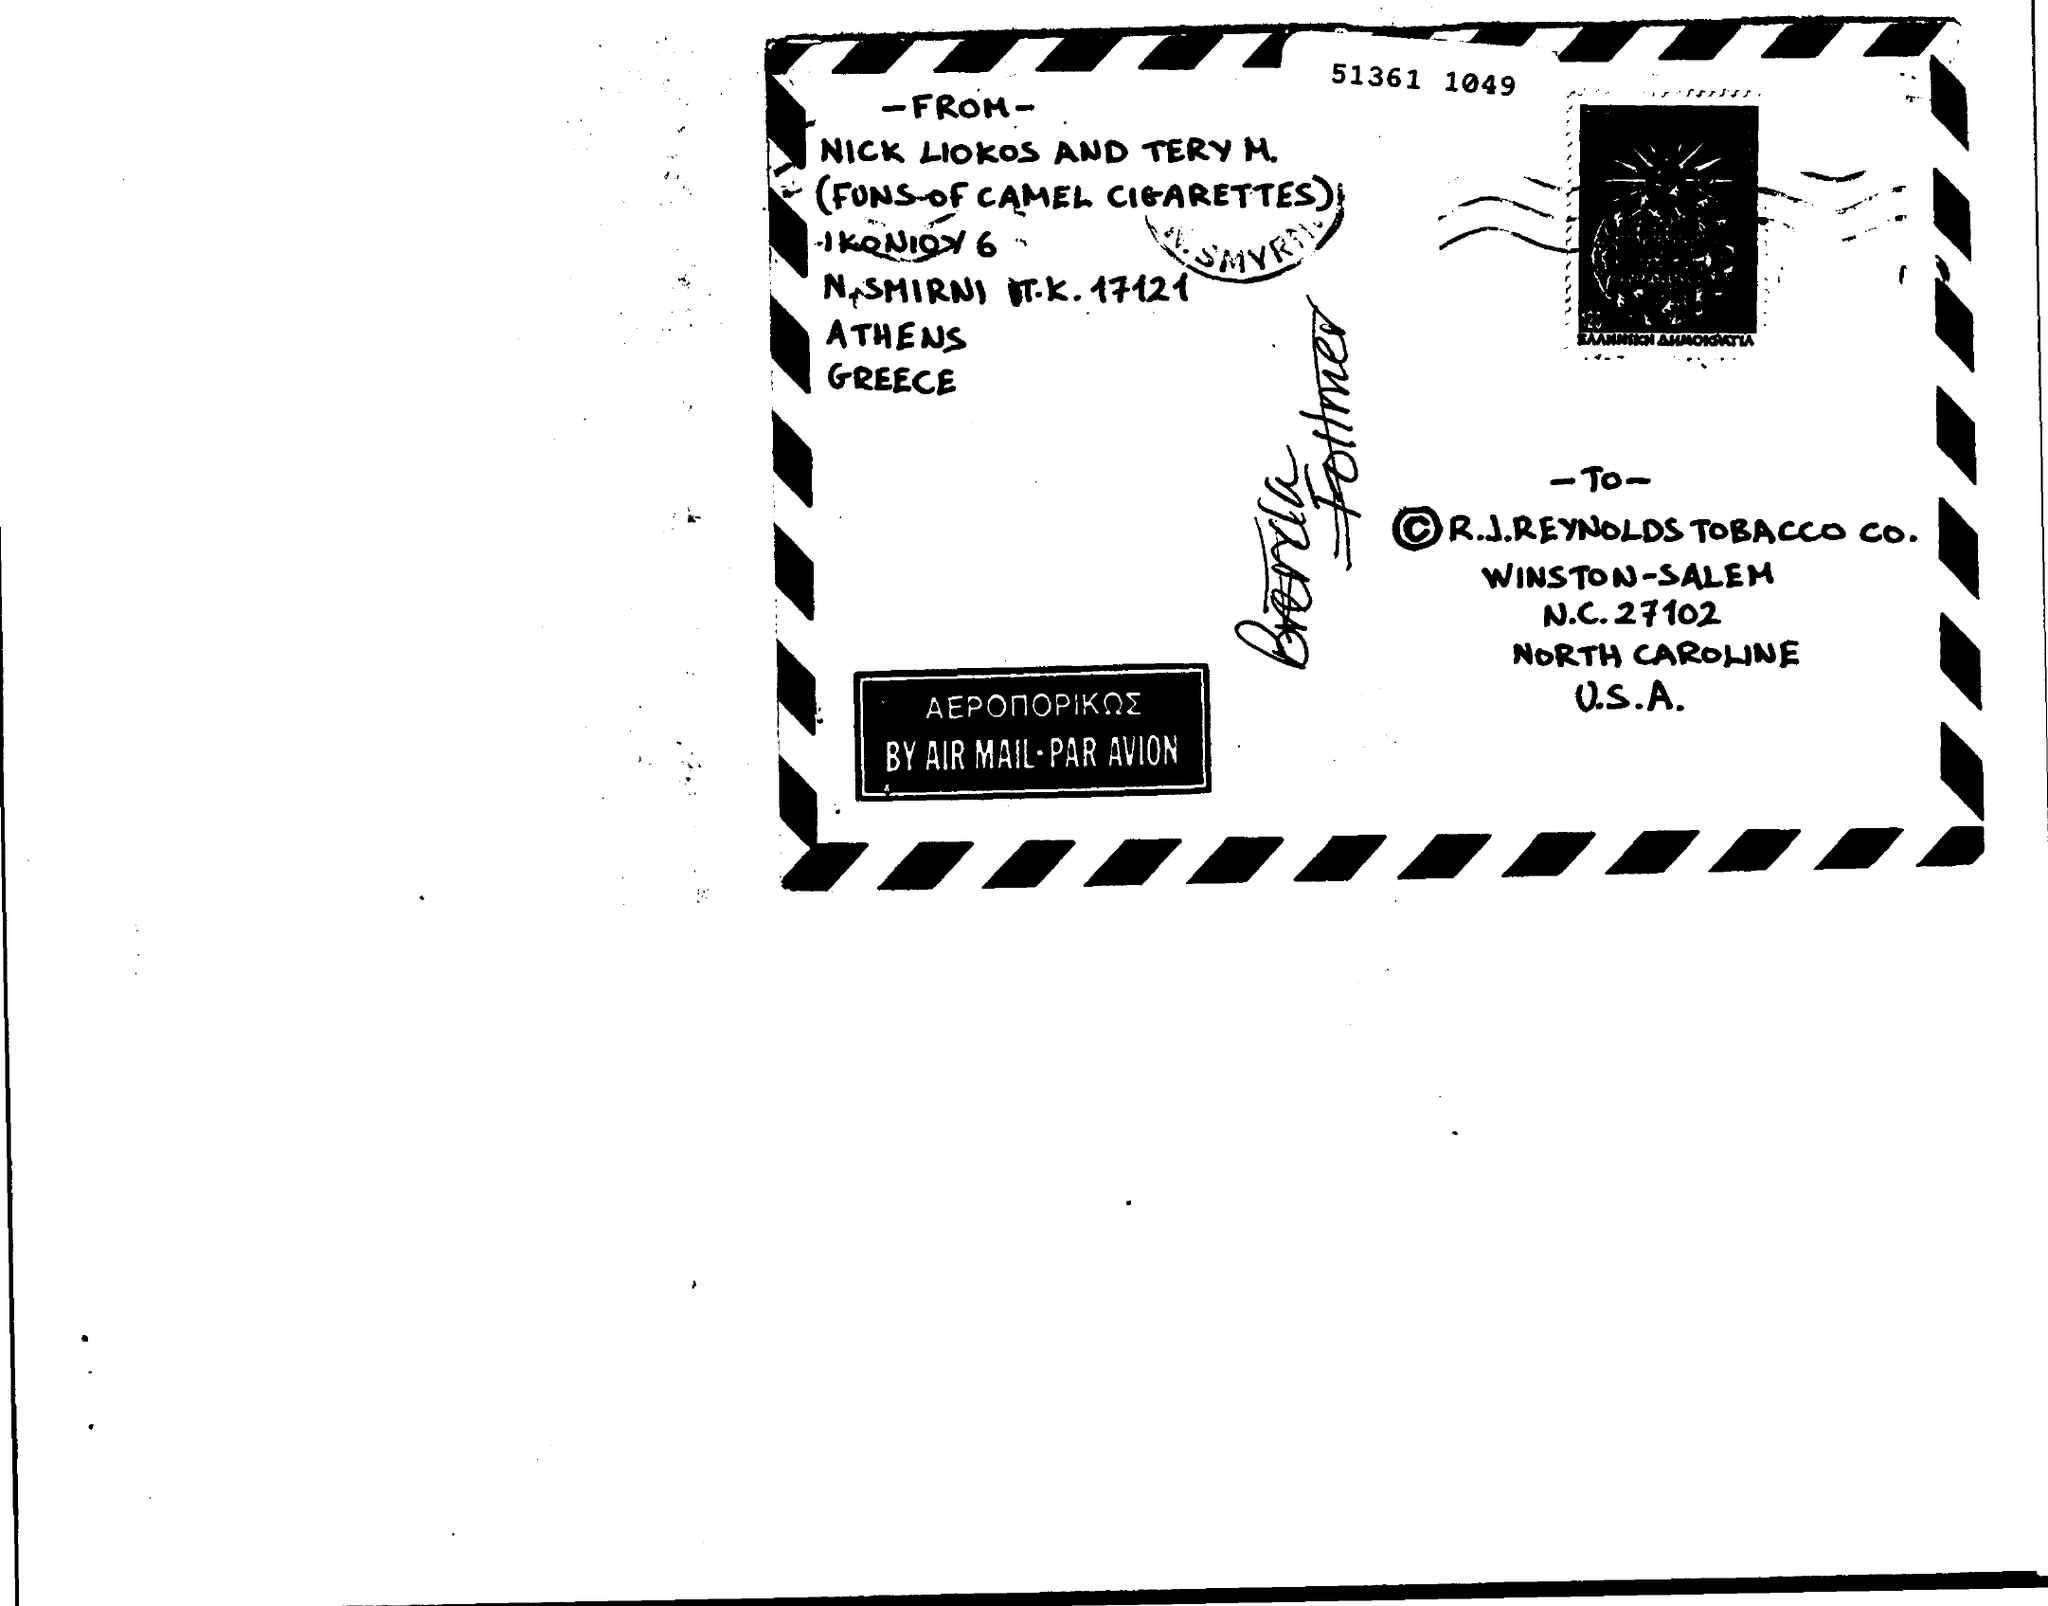Draw attention to some important aspects in this diagram. The memorandum is from Nick Liokos and Tery M... A memorandum addressed to R.J. Reynolds Tobacco Company is asking for information regarding the amount of cigarettes sold in a certain state. 